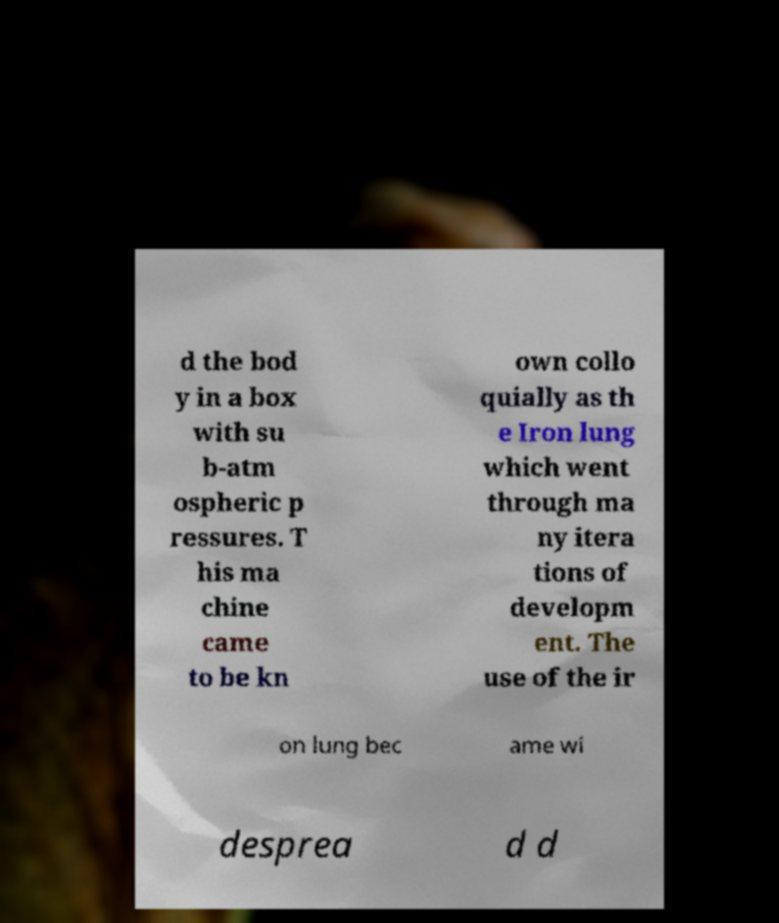Can you read and provide the text displayed in the image?This photo seems to have some interesting text. Can you extract and type it out for me? d the bod y in a box with su b-atm ospheric p ressures. T his ma chine came to be kn own collo quially as th e Iron lung which went through ma ny itera tions of developm ent. The use of the ir on lung bec ame wi desprea d d 